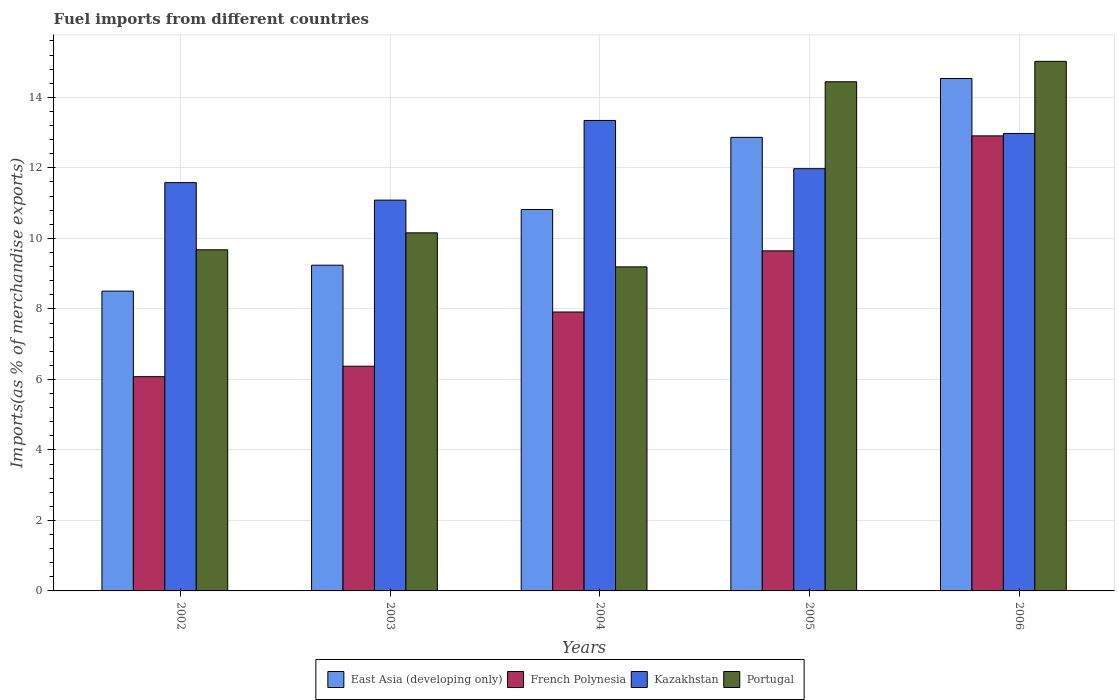How many different coloured bars are there?
Make the answer very short. 4. Are the number of bars on each tick of the X-axis equal?
Your answer should be very brief. Yes. How many bars are there on the 4th tick from the right?
Your answer should be compact. 4. What is the label of the 1st group of bars from the left?
Your answer should be very brief. 2002. In how many cases, is the number of bars for a given year not equal to the number of legend labels?
Give a very brief answer. 0. What is the percentage of imports to different countries in East Asia (developing only) in 2006?
Keep it short and to the point. 14.54. Across all years, what is the maximum percentage of imports to different countries in Kazakhstan?
Offer a terse response. 13.35. Across all years, what is the minimum percentage of imports to different countries in French Polynesia?
Your response must be concise. 6.08. In which year was the percentage of imports to different countries in Portugal minimum?
Make the answer very short. 2004. What is the total percentage of imports to different countries in Kazakhstan in the graph?
Offer a terse response. 60.97. What is the difference between the percentage of imports to different countries in Kazakhstan in 2002 and that in 2003?
Provide a succinct answer. 0.5. What is the difference between the percentage of imports to different countries in East Asia (developing only) in 2005 and the percentage of imports to different countries in Portugal in 2006?
Ensure brevity in your answer.  -2.16. What is the average percentage of imports to different countries in French Polynesia per year?
Offer a terse response. 8.58. In the year 2006, what is the difference between the percentage of imports to different countries in Kazakhstan and percentage of imports to different countries in Portugal?
Ensure brevity in your answer.  -2.05. What is the ratio of the percentage of imports to different countries in French Polynesia in 2003 to that in 2005?
Your answer should be compact. 0.66. Is the percentage of imports to different countries in Kazakhstan in 2002 less than that in 2003?
Your answer should be compact. No. Is the difference between the percentage of imports to different countries in Kazakhstan in 2004 and 2005 greater than the difference between the percentage of imports to different countries in Portugal in 2004 and 2005?
Your answer should be very brief. Yes. What is the difference between the highest and the second highest percentage of imports to different countries in Kazakhstan?
Ensure brevity in your answer.  0.37. What is the difference between the highest and the lowest percentage of imports to different countries in Portugal?
Your answer should be compact. 5.83. In how many years, is the percentage of imports to different countries in East Asia (developing only) greater than the average percentage of imports to different countries in East Asia (developing only) taken over all years?
Provide a succinct answer. 2. What does the 1st bar from the left in 2003 represents?
Provide a succinct answer. East Asia (developing only). What does the 3rd bar from the right in 2003 represents?
Give a very brief answer. French Polynesia. Is it the case that in every year, the sum of the percentage of imports to different countries in East Asia (developing only) and percentage of imports to different countries in French Polynesia is greater than the percentage of imports to different countries in Kazakhstan?
Your response must be concise. Yes. How many bars are there?
Provide a succinct answer. 20. Are all the bars in the graph horizontal?
Your answer should be very brief. No. How many years are there in the graph?
Offer a very short reply. 5. Are the values on the major ticks of Y-axis written in scientific E-notation?
Offer a very short reply. No. Does the graph contain any zero values?
Your answer should be very brief. No. What is the title of the graph?
Offer a very short reply. Fuel imports from different countries. Does "French Polynesia" appear as one of the legend labels in the graph?
Provide a succinct answer. Yes. What is the label or title of the Y-axis?
Keep it short and to the point. Imports(as % of merchandise exports). What is the Imports(as % of merchandise exports) of East Asia (developing only) in 2002?
Your answer should be compact. 8.5. What is the Imports(as % of merchandise exports) in French Polynesia in 2002?
Your answer should be very brief. 6.08. What is the Imports(as % of merchandise exports) in Kazakhstan in 2002?
Ensure brevity in your answer.  11.58. What is the Imports(as % of merchandise exports) in Portugal in 2002?
Keep it short and to the point. 9.68. What is the Imports(as % of merchandise exports) in East Asia (developing only) in 2003?
Ensure brevity in your answer.  9.24. What is the Imports(as % of merchandise exports) in French Polynesia in 2003?
Your answer should be compact. 6.37. What is the Imports(as % of merchandise exports) of Kazakhstan in 2003?
Ensure brevity in your answer.  11.09. What is the Imports(as % of merchandise exports) in Portugal in 2003?
Provide a short and direct response. 10.16. What is the Imports(as % of merchandise exports) of East Asia (developing only) in 2004?
Your answer should be compact. 10.82. What is the Imports(as % of merchandise exports) in French Polynesia in 2004?
Your answer should be very brief. 7.91. What is the Imports(as % of merchandise exports) in Kazakhstan in 2004?
Offer a very short reply. 13.35. What is the Imports(as % of merchandise exports) in Portugal in 2004?
Offer a very short reply. 9.19. What is the Imports(as % of merchandise exports) in East Asia (developing only) in 2005?
Make the answer very short. 12.87. What is the Imports(as % of merchandise exports) of French Polynesia in 2005?
Your answer should be very brief. 9.65. What is the Imports(as % of merchandise exports) of Kazakhstan in 2005?
Give a very brief answer. 11.98. What is the Imports(as % of merchandise exports) of Portugal in 2005?
Ensure brevity in your answer.  14.44. What is the Imports(as % of merchandise exports) of East Asia (developing only) in 2006?
Your answer should be very brief. 14.54. What is the Imports(as % of merchandise exports) in French Polynesia in 2006?
Give a very brief answer. 12.91. What is the Imports(as % of merchandise exports) of Kazakhstan in 2006?
Offer a terse response. 12.98. What is the Imports(as % of merchandise exports) of Portugal in 2006?
Make the answer very short. 15.02. Across all years, what is the maximum Imports(as % of merchandise exports) of East Asia (developing only)?
Provide a short and direct response. 14.54. Across all years, what is the maximum Imports(as % of merchandise exports) in French Polynesia?
Provide a short and direct response. 12.91. Across all years, what is the maximum Imports(as % of merchandise exports) in Kazakhstan?
Make the answer very short. 13.35. Across all years, what is the maximum Imports(as % of merchandise exports) of Portugal?
Your response must be concise. 15.02. Across all years, what is the minimum Imports(as % of merchandise exports) of East Asia (developing only)?
Ensure brevity in your answer.  8.5. Across all years, what is the minimum Imports(as % of merchandise exports) in French Polynesia?
Ensure brevity in your answer.  6.08. Across all years, what is the minimum Imports(as % of merchandise exports) of Kazakhstan?
Ensure brevity in your answer.  11.09. Across all years, what is the minimum Imports(as % of merchandise exports) in Portugal?
Provide a succinct answer. 9.19. What is the total Imports(as % of merchandise exports) in East Asia (developing only) in the graph?
Keep it short and to the point. 55.97. What is the total Imports(as % of merchandise exports) in French Polynesia in the graph?
Make the answer very short. 42.92. What is the total Imports(as % of merchandise exports) in Kazakhstan in the graph?
Keep it short and to the point. 60.97. What is the total Imports(as % of merchandise exports) in Portugal in the graph?
Provide a short and direct response. 58.49. What is the difference between the Imports(as % of merchandise exports) of East Asia (developing only) in 2002 and that in 2003?
Offer a very short reply. -0.74. What is the difference between the Imports(as % of merchandise exports) in French Polynesia in 2002 and that in 2003?
Make the answer very short. -0.3. What is the difference between the Imports(as % of merchandise exports) of Kazakhstan in 2002 and that in 2003?
Your answer should be very brief. 0.5. What is the difference between the Imports(as % of merchandise exports) in Portugal in 2002 and that in 2003?
Offer a terse response. -0.48. What is the difference between the Imports(as % of merchandise exports) in East Asia (developing only) in 2002 and that in 2004?
Provide a short and direct response. -2.32. What is the difference between the Imports(as % of merchandise exports) of French Polynesia in 2002 and that in 2004?
Offer a very short reply. -1.83. What is the difference between the Imports(as % of merchandise exports) of Kazakhstan in 2002 and that in 2004?
Your response must be concise. -1.76. What is the difference between the Imports(as % of merchandise exports) in Portugal in 2002 and that in 2004?
Your answer should be compact. 0.48. What is the difference between the Imports(as % of merchandise exports) in East Asia (developing only) in 2002 and that in 2005?
Your answer should be compact. -4.36. What is the difference between the Imports(as % of merchandise exports) in French Polynesia in 2002 and that in 2005?
Ensure brevity in your answer.  -3.57. What is the difference between the Imports(as % of merchandise exports) of Kazakhstan in 2002 and that in 2005?
Offer a terse response. -0.4. What is the difference between the Imports(as % of merchandise exports) in Portugal in 2002 and that in 2005?
Offer a terse response. -4.77. What is the difference between the Imports(as % of merchandise exports) in East Asia (developing only) in 2002 and that in 2006?
Your answer should be compact. -6.03. What is the difference between the Imports(as % of merchandise exports) of French Polynesia in 2002 and that in 2006?
Your response must be concise. -6.83. What is the difference between the Imports(as % of merchandise exports) in Kazakhstan in 2002 and that in 2006?
Offer a very short reply. -1.39. What is the difference between the Imports(as % of merchandise exports) in Portugal in 2002 and that in 2006?
Your response must be concise. -5.35. What is the difference between the Imports(as % of merchandise exports) of East Asia (developing only) in 2003 and that in 2004?
Your answer should be compact. -1.58. What is the difference between the Imports(as % of merchandise exports) in French Polynesia in 2003 and that in 2004?
Your answer should be very brief. -1.54. What is the difference between the Imports(as % of merchandise exports) in Kazakhstan in 2003 and that in 2004?
Offer a terse response. -2.26. What is the difference between the Imports(as % of merchandise exports) in Portugal in 2003 and that in 2004?
Keep it short and to the point. 0.97. What is the difference between the Imports(as % of merchandise exports) of East Asia (developing only) in 2003 and that in 2005?
Provide a short and direct response. -3.63. What is the difference between the Imports(as % of merchandise exports) of French Polynesia in 2003 and that in 2005?
Offer a very short reply. -3.27. What is the difference between the Imports(as % of merchandise exports) of Kazakhstan in 2003 and that in 2005?
Ensure brevity in your answer.  -0.89. What is the difference between the Imports(as % of merchandise exports) in Portugal in 2003 and that in 2005?
Offer a very short reply. -4.29. What is the difference between the Imports(as % of merchandise exports) of East Asia (developing only) in 2003 and that in 2006?
Provide a succinct answer. -5.3. What is the difference between the Imports(as % of merchandise exports) of French Polynesia in 2003 and that in 2006?
Offer a terse response. -6.53. What is the difference between the Imports(as % of merchandise exports) in Kazakhstan in 2003 and that in 2006?
Give a very brief answer. -1.89. What is the difference between the Imports(as % of merchandise exports) of Portugal in 2003 and that in 2006?
Keep it short and to the point. -4.86. What is the difference between the Imports(as % of merchandise exports) in East Asia (developing only) in 2004 and that in 2005?
Provide a succinct answer. -2.05. What is the difference between the Imports(as % of merchandise exports) of French Polynesia in 2004 and that in 2005?
Make the answer very short. -1.73. What is the difference between the Imports(as % of merchandise exports) of Kazakhstan in 2004 and that in 2005?
Your response must be concise. 1.37. What is the difference between the Imports(as % of merchandise exports) in Portugal in 2004 and that in 2005?
Your answer should be compact. -5.25. What is the difference between the Imports(as % of merchandise exports) of East Asia (developing only) in 2004 and that in 2006?
Offer a very short reply. -3.72. What is the difference between the Imports(as % of merchandise exports) in French Polynesia in 2004 and that in 2006?
Offer a terse response. -5. What is the difference between the Imports(as % of merchandise exports) in Kazakhstan in 2004 and that in 2006?
Ensure brevity in your answer.  0.37. What is the difference between the Imports(as % of merchandise exports) in Portugal in 2004 and that in 2006?
Provide a succinct answer. -5.83. What is the difference between the Imports(as % of merchandise exports) of East Asia (developing only) in 2005 and that in 2006?
Provide a succinct answer. -1.67. What is the difference between the Imports(as % of merchandise exports) of French Polynesia in 2005 and that in 2006?
Keep it short and to the point. -3.26. What is the difference between the Imports(as % of merchandise exports) of Kazakhstan in 2005 and that in 2006?
Ensure brevity in your answer.  -1. What is the difference between the Imports(as % of merchandise exports) in Portugal in 2005 and that in 2006?
Provide a short and direct response. -0.58. What is the difference between the Imports(as % of merchandise exports) in East Asia (developing only) in 2002 and the Imports(as % of merchandise exports) in French Polynesia in 2003?
Your response must be concise. 2.13. What is the difference between the Imports(as % of merchandise exports) of East Asia (developing only) in 2002 and the Imports(as % of merchandise exports) of Kazakhstan in 2003?
Your answer should be very brief. -2.58. What is the difference between the Imports(as % of merchandise exports) of East Asia (developing only) in 2002 and the Imports(as % of merchandise exports) of Portugal in 2003?
Your response must be concise. -1.65. What is the difference between the Imports(as % of merchandise exports) in French Polynesia in 2002 and the Imports(as % of merchandise exports) in Kazakhstan in 2003?
Offer a terse response. -5.01. What is the difference between the Imports(as % of merchandise exports) in French Polynesia in 2002 and the Imports(as % of merchandise exports) in Portugal in 2003?
Keep it short and to the point. -4.08. What is the difference between the Imports(as % of merchandise exports) of Kazakhstan in 2002 and the Imports(as % of merchandise exports) of Portugal in 2003?
Your answer should be compact. 1.42. What is the difference between the Imports(as % of merchandise exports) of East Asia (developing only) in 2002 and the Imports(as % of merchandise exports) of French Polynesia in 2004?
Offer a very short reply. 0.59. What is the difference between the Imports(as % of merchandise exports) in East Asia (developing only) in 2002 and the Imports(as % of merchandise exports) in Kazakhstan in 2004?
Provide a succinct answer. -4.84. What is the difference between the Imports(as % of merchandise exports) in East Asia (developing only) in 2002 and the Imports(as % of merchandise exports) in Portugal in 2004?
Keep it short and to the point. -0.69. What is the difference between the Imports(as % of merchandise exports) of French Polynesia in 2002 and the Imports(as % of merchandise exports) of Kazakhstan in 2004?
Your response must be concise. -7.27. What is the difference between the Imports(as % of merchandise exports) in French Polynesia in 2002 and the Imports(as % of merchandise exports) in Portugal in 2004?
Offer a very short reply. -3.11. What is the difference between the Imports(as % of merchandise exports) of Kazakhstan in 2002 and the Imports(as % of merchandise exports) of Portugal in 2004?
Ensure brevity in your answer.  2.39. What is the difference between the Imports(as % of merchandise exports) of East Asia (developing only) in 2002 and the Imports(as % of merchandise exports) of French Polynesia in 2005?
Your answer should be very brief. -1.14. What is the difference between the Imports(as % of merchandise exports) in East Asia (developing only) in 2002 and the Imports(as % of merchandise exports) in Kazakhstan in 2005?
Give a very brief answer. -3.47. What is the difference between the Imports(as % of merchandise exports) in East Asia (developing only) in 2002 and the Imports(as % of merchandise exports) in Portugal in 2005?
Your response must be concise. -5.94. What is the difference between the Imports(as % of merchandise exports) of French Polynesia in 2002 and the Imports(as % of merchandise exports) of Kazakhstan in 2005?
Provide a succinct answer. -5.9. What is the difference between the Imports(as % of merchandise exports) of French Polynesia in 2002 and the Imports(as % of merchandise exports) of Portugal in 2005?
Make the answer very short. -8.37. What is the difference between the Imports(as % of merchandise exports) in Kazakhstan in 2002 and the Imports(as % of merchandise exports) in Portugal in 2005?
Provide a succinct answer. -2.86. What is the difference between the Imports(as % of merchandise exports) in East Asia (developing only) in 2002 and the Imports(as % of merchandise exports) in French Polynesia in 2006?
Offer a terse response. -4.4. What is the difference between the Imports(as % of merchandise exports) of East Asia (developing only) in 2002 and the Imports(as % of merchandise exports) of Kazakhstan in 2006?
Provide a succinct answer. -4.47. What is the difference between the Imports(as % of merchandise exports) of East Asia (developing only) in 2002 and the Imports(as % of merchandise exports) of Portugal in 2006?
Provide a succinct answer. -6.52. What is the difference between the Imports(as % of merchandise exports) in French Polynesia in 2002 and the Imports(as % of merchandise exports) in Kazakhstan in 2006?
Ensure brevity in your answer.  -6.9. What is the difference between the Imports(as % of merchandise exports) in French Polynesia in 2002 and the Imports(as % of merchandise exports) in Portugal in 2006?
Keep it short and to the point. -8.94. What is the difference between the Imports(as % of merchandise exports) of Kazakhstan in 2002 and the Imports(as % of merchandise exports) of Portugal in 2006?
Your answer should be compact. -3.44. What is the difference between the Imports(as % of merchandise exports) in East Asia (developing only) in 2003 and the Imports(as % of merchandise exports) in French Polynesia in 2004?
Make the answer very short. 1.33. What is the difference between the Imports(as % of merchandise exports) of East Asia (developing only) in 2003 and the Imports(as % of merchandise exports) of Kazakhstan in 2004?
Offer a terse response. -4.11. What is the difference between the Imports(as % of merchandise exports) in East Asia (developing only) in 2003 and the Imports(as % of merchandise exports) in Portugal in 2004?
Offer a very short reply. 0.05. What is the difference between the Imports(as % of merchandise exports) of French Polynesia in 2003 and the Imports(as % of merchandise exports) of Kazakhstan in 2004?
Your answer should be compact. -6.97. What is the difference between the Imports(as % of merchandise exports) in French Polynesia in 2003 and the Imports(as % of merchandise exports) in Portugal in 2004?
Your response must be concise. -2.82. What is the difference between the Imports(as % of merchandise exports) of Kazakhstan in 2003 and the Imports(as % of merchandise exports) of Portugal in 2004?
Your response must be concise. 1.89. What is the difference between the Imports(as % of merchandise exports) in East Asia (developing only) in 2003 and the Imports(as % of merchandise exports) in French Polynesia in 2005?
Make the answer very short. -0.41. What is the difference between the Imports(as % of merchandise exports) of East Asia (developing only) in 2003 and the Imports(as % of merchandise exports) of Kazakhstan in 2005?
Provide a short and direct response. -2.74. What is the difference between the Imports(as % of merchandise exports) in East Asia (developing only) in 2003 and the Imports(as % of merchandise exports) in Portugal in 2005?
Give a very brief answer. -5.2. What is the difference between the Imports(as % of merchandise exports) of French Polynesia in 2003 and the Imports(as % of merchandise exports) of Kazakhstan in 2005?
Provide a short and direct response. -5.6. What is the difference between the Imports(as % of merchandise exports) in French Polynesia in 2003 and the Imports(as % of merchandise exports) in Portugal in 2005?
Make the answer very short. -8.07. What is the difference between the Imports(as % of merchandise exports) of Kazakhstan in 2003 and the Imports(as % of merchandise exports) of Portugal in 2005?
Offer a terse response. -3.36. What is the difference between the Imports(as % of merchandise exports) of East Asia (developing only) in 2003 and the Imports(as % of merchandise exports) of French Polynesia in 2006?
Your answer should be very brief. -3.67. What is the difference between the Imports(as % of merchandise exports) of East Asia (developing only) in 2003 and the Imports(as % of merchandise exports) of Kazakhstan in 2006?
Provide a short and direct response. -3.74. What is the difference between the Imports(as % of merchandise exports) of East Asia (developing only) in 2003 and the Imports(as % of merchandise exports) of Portugal in 2006?
Make the answer very short. -5.78. What is the difference between the Imports(as % of merchandise exports) of French Polynesia in 2003 and the Imports(as % of merchandise exports) of Kazakhstan in 2006?
Make the answer very short. -6.6. What is the difference between the Imports(as % of merchandise exports) of French Polynesia in 2003 and the Imports(as % of merchandise exports) of Portugal in 2006?
Offer a very short reply. -8.65. What is the difference between the Imports(as % of merchandise exports) of Kazakhstan in 2003 and the Imports(as % of merchandise exports) of Portugal in 2006?
Your answer should be very brief. -3.94. What is the difference between the Imports(as % of merchandise exports) in East Asia (developing only) in 2004 and the Imports(as % of merchandise exports) in French Polynesia in 2005?
Your answer should be very brief. 1.17. What is the difference between the Imports(as % of merchandise exports) in East Asia (developing only) in 2004 and the Imports(as % of merchandise exports) in Kazakhstan in 2005?
Keep it short and to the point. -1.16. What is the difference between the Imports(as % of merchandise exports) of East Asia (developing only) in 2004 and the Imports(as % of merchandise exports) of Portugal in 2005?
Your answer should be very brief. -3.62. What is the difference between the Imports(as % of merchandise exports) in French Polynesia in 2004 and the Imports(as % of merchandise exports) in Kazakhstan in 2005?
Keep it short and to the point. -4.07. What is the difference between the Imports(as % of merchandise exports) in French Polynesia in 2004 and the Imports(as % of merchandise exports) in Portugal in 2005?
Give a very brief answer. -6.53. What is the difference between the Imports(as % of merchandise exports) of Kazakhstan in 2004 and the Imports(as % of merchandise exports) of Portugal in 2005?
Offer a very short reply. -1.1. What is the difference between the Imports(as % of merchandise exports) in East Asia (developing only) in 2004 and the Imports(as % of merchandise exports) in French Polynesia in 2006?
Give a very brief answer. -2.09. What is the difference between the Imports(as % of merchandise exports) in East Asia (developing only) in 2004 and the Imports(as % of merchandise exports) in Kazakhstan in 2006?
Make the answer very short. -2.16. What is the difference between the Imports(as % of merchandise exports) in East Asia (developing only) in 2004 and the Imports(as % of merchandise exports) in Portugal in 2006?
Your answer should be compact. -4.2. What is the difference between the Imports(as % of merchandise exports) in French Polynesia in 2004 and the Imports(as % of merchandise exports) in Kazakhstan in 2006?
Your answer should be very brief. -5.06. What is the difference between the Imports(as % of merchandise exports) of French Polynesia in 2004 and the Imports(as % of merchandise exports) of Portugal in 2006?
Your response must be concise. -7.11. What is the difference between the Imports(as % of merchandise exports) of Kazakhstan in 2004 and the Imports(as % of merchandise exports) of Portugal in 2006?
Offer a very short reply. -1.68. What is the difference between the Imports(as % of merchandise exports) in East Asia (developing only) in 2005 and the Imports(as % of merchandise exports) in French Polynesia in 2006?
Your response must be concise. -0.04. What is the difference between the Imports(as % of merchandise exports) of East Asia (developing only) in 2005 and the Imports(as % of merchandise exports) of Kazakhstan in 2006?
Keep it short and to the point. -0.11. What is the difference between the Imports(as % of merchandise exports) of East Asia (developing only) in 2005 and the Imports(as % of merchandise exports) of Portugal in 2006?
Your answer should be very brief. -2.16. What is the difference between the Imports(as % of merchandise exports) in French Polynesia in 2005 and the Imports(as % of merchandise exports) in Kazakhstan in 2006?
Make the answer very short. -3.33. What is the difference between the Imports(as % of merchandise exports) of French Polynesia in 2005 and the Imports(as % of merchandise exports) of Portugal in 2006?
Ensure brevity in your answer.  -5.38. What is the difference between the Imports(as % of merchandise exports) of Kazakhstan in 2005 and the Imports(as % of merchandise exports) of Portugal in 2006?
Your answer should be very brief. -3.04. What is the average Imports(as % of merchandise exports) of East Asia (developing only) per year?
Ensure brevity in your answer.  11.19. What is the average Imports(as % of merchandise exports) in French Polynesia per year?
Give a very brief answer. 8.58. What is the average Imports(as % of merchandise exports) of Kazakhstan per year?
Offer a terse response. 12.19. What is the average Imports(as % of merchandise exports) in Portugal per year?
Keep it short and to the point. 11.7. In the year 2002, what is the difference between the Imports(as % of merchandise exports) in East Asia (developing only) and Imports(as % of merchandise exports) in French Polynesia?
Keep it short and to the point. 2.43. In the year 2002, what is the difference between the Imports(as % of merchandise exports) of East Asia (developing only) and Imports(as % of merchandise exports) of Kazakhstan?
Make the answer very short. -3.08. In the year 2002, what is the difference between the Imports(as % of merchandise exports) of East Asia (developing only) and Imports(as % of merchandise exports) of Portugal?
Provide a short and direct response. -1.17. In the year 2002, what is the difference between the Imports(as % of merchandise exports) in French Polynesia and Imports(as % of merchandise exports) in Kazakhstan?
Your answer should be very brief. -5.5. In the year 2002, what is the difference between the Imports(as % of merchandise exports) in French Polynesia and Imports(as % of merchandise exports) in Portugal?
Ensure brevity in your answer.  -3.6. In the year 2002, what is the difference between the Imports(as % of merchandise exports) of Kazakhstan and Imports(as % of merchandise exports) of Portugal?
Your answer should be compact. 1.91. In the year 2003, what is the difference between the Imports(as % of merchandise exports) of East Asia (developing only) and Imports(as % of merchandise exports) of French Polynesia?
Offer a very short reply. 2.87. In the year 2003, what is the difference between the Imports(as % of merchandise exports) of East Asia (developing only) and Imports(as % of merchandise exports) of Kazakhstan?
Offer a terse response. -1.85. In the year 2003, what is the difference between the Imports(as % of merchandise exports) of East Asia (developing only) and Imports(as % of merchandise exports) of Portugal?
Make the answer very short. -0.92. In the year 2003, what is the difference between the Imports(as % of merchandise exports) in French Polynesia and Imports(as % of merchandise exports) in Kazakhstan?
Give a very brief answer. -4.71. In the year 2003, what is the difference between the Imports(as % of merchandise exports) of French Polynesia and Imports(as % of merchandise exports) of Portugal?
Make the answer very short. -3.78. In the year 2003, what is the difference between the Imports(as % of merchandise exports) of Kazakhstan and Imports(as % of merchandise exports) of Portugal?
Offer a terse response. 0.93. In the year 2004, what is the difference between the Imports(as % of merchandise exports) in East Asia (developing only) and Imports(as % of merchandise exports) in French Polynesia?
Keep it short and to the point. 2.91. In the year 2004, what is the difference between the Imports(as % of merchandise exports) in East Asia (developing only) and Imports(as % of merchandise exports) in Kazakhstan?
Keep it short and to the point. -2.53. In the year 2004, what is the difference between the Imports(as % of merchandise exports) of East Asia (developing only) and Imports(as % of merchandise exports) of Portugal?
Provide a succinct answer. 1.63. In the year 2004, what is the difference between the Imports(as % of merchandise exports) in French Polynesia and Imports(as % of merchandise exports) in Kazakhstan?
Ensure brevity in your answer.  -5.43. In the year 2004, what is the difference between the Imports(as % of merchandise exports) in French Polynesia and Imports(as % of merchandise exports) in Portugal?
Offer a terse response. -1.28. In the year 2004, what is the difference between the Imports(as % of merchandise exports) in Kazakhstan and Imports(as % of merchandise exports) in Portugal?
Your answer should be compact. 4.15. In the year 2005, what is the difference between the Imports(as % of merchandise exports) in East Asia (developing only) and Imports(as % of merchandise exports) in French Polynesia?
Offer a very short reply. 3.22. In the year 2005, what is the difference between the Imports(as % of merchandise exports) in East Asia (developing only) and Imports(as % of merchandise exports) in Kazakhstan?
Provide a succinct answer. 0.89. In the year 2005, what is the difference between the Imports(as % of merchandise exports) of East Asia (developing only) and Imports(as % of merchandise exports) of Portugal?
Provide a succinct answer. -1.58. In the year 2005, what is the difference between the Imports(as % of merchandise exports) in French Polynesia and Imports(as % of merchandise exports) in Kazakhstan?
Provide a short and direct response. -2.33. In the year 2005, what is the difference between the Imports(as % of merchandise exports) of French Polynesia and Imports(as % of merchandise exports) of Portugal?
Your answer should be very brief. -4.8. In the year 2005, what is the difference between the Imports(as % of merchandise exports) in Kazakhstan and Imports(as % of merchandise exports) in Portugal?
Offer a terse response. -2.47. In the year 2006, what is the difference between the Imports(as % of merchandise exports) of East Asia (developing only) and Imports(as % of merchandise exports) of French Polynesia?
Your response must be concise. 1.63. In the year 2006, what is the difference between the Imports(as % of merchandise exports) of East Asia (developing only) and Imports(as % of merchandise exports) of Kazakhstan?
Provide a succinct answer. 1.56. In the year 2006, what is the difference between the Imports(as % of merchandise exports) in East Asia (developing only) and Imports(as % of merchandise exports) in Portugal?
Your answer should be very brief. -0.49. In the year 2006, what is the difference between the Imports(as % of merchandise exports) in French Polynesia and Imports(as % of merchandise exports) in Kazakhstan?
Offer a terse response. -0.07. In the year 2006, what is the difference between the Imports(as % of merchandise exports) in French Polynesia and Imports(as % of merchandise exports) in Portugal?
Make the answer very short. -2.11. In the year 2006, what is the difference between the Imports(as % of merchandise exports) of Kazakhstan and Imports(as % of merchandise exports) of Portugal?
Your response must be concise. -2.05. What is the ratio of the Imports(as % of merchandise exports) in East Asia (developing only) in 2002 to that in 2003?
Your answer should be compact. 0.92. What is the ratio of the Imports(as % of merchandise exports) of French Polynesia in 2002 to that in 2003?
Give a very brief answer. 0.95. What is the ratio of the Imports(as % of merchandise exports) in Kazakhstan in 2002 to that in 2003?
Your answer should be compact. 1.04. What is the ratio of the Imports(as % of merchandise exports) in Portugal in 2002 to that in 2003?
Provide a succinct answer. 0.95. What is the ratio of the Imports(as % of merchandise exports) of East Asia (developing only) in 2002 to that in 2004?
Ensure brevity in your answer.  0.79. What is the ratio of the Imports(as % of merchandise exports) in French Polynesia in 2002 to that in 2004?
Your answer should be very brief. 0.77. What is the ratio of the Imports(as % of merchandise exports) in Kazakhstan in 2002 to that in 2004?
Keep it short and to the point. 0.87. What is the ratio of the Imports(as % of merchandise exports) in Portugal in 2002 to that in 2004?
Your response must be concise. 1.05. What is the ratio of the Imports(as % of merchandise exports) of East Asia (developing only) in 2002 to that in 2005?
Make the answer very short. 0.66. What is the ratio of the Imports(as % of merchandise exports) in French Polynesia in 2002 to that in 2005?
Provide a succinct answer. 0.63. What is the ratio of the Imports(as % of merchandise exports) of Kazakhstan in 2002 to that in 2005?
Ensure brevity in your answer.  0.97. What is the ratio of the Imports(as % of merchandise exports) in Portugal in 2002 to that in 2005?
Offer a terse response. 0.67. What is the ratio of the Imports(as % of merchandise exports) in East Asia (developing only) in 2002 to that in 2006?
Your answer should be compact. 0.59. What is the ratio of the Imports(as % of merchandise exports) of French Polynesia in 2002 to that in 2006?
Your response must be concise. 0.47. What is the ratio of the Imports(as % of merchandise exports) of Kazakhstan in 2002 to that in 2006?
Provide a short and direct response. 0.89. What is the ratio of the Imports(as % of merchandise exports) in Portugal in 2002 to that in 2006?
Give a very brief answer. 0.64. What is the ratio of the Imports(as % of merchandise exports) in East Asia (developing only) in 2003 to that in 2004?
Your answer should be compact. 0.85. What is the ratio of the Imports(as % of merchandise exports) in French Polynesia in 2003 to that in 2004?
Your response must be concise. 0.81. What is the ratio of the Imports(as % of merchandise exports) in Kazakhstan in 2003 to that in 2004?
Your answer should be compact. 0.83. What is the ratio of the Imports(as % of merchandise exports) in Portugal in 2003 to that in 2004?
Offer a very short reply. 1.1. What is the ratio of the Imports(as % of merchandise exports) of East Asia (developing only) in 2003 to that in 2005?
Give a very brief answer. 0.72. What is the ratio of the Imports(as % of merchandise exports) in French Polynesia in 2003 to that in 2005?
Provide a succinct answer. 0.66. What is the ratio of the Imports(as % of merchandise exports) in Kazakhstan in 2003 to that in 2005?
Give a very brief answer. 0.93. What is the ratio of the Imports(as % of merchandise exports) of Portugal in 2003 to that in 2005?
Provide a short and direct response. 0.7. What is the ratio of the Imports(as % of merchandise exports) in East Asia (developing only) in 2003 to that in 2006?
Give a very brief answer. 0.64. What is the ratio of the Imports(as % of merchandise exports) of French Polynesia in 2003 to that in 2006?
Your answer should be very brief. 0.49. What is the ratio of the Imports(as % of merchandise exports) in Kazakhstan in 2003 to that in 2006?
Give a very brief answer. 0.85. What is the ratio of the Imports(as % of merchandise exports) of Portugal in 2003 to that in 2006?
Provide a short and direct response. 0.68. What is the ratio of the Imports(as % of merchandise exports) of East Asia (developing only) in 2004 to that in 2005?
Your response must be concise. 0.84. What is the ratio of the Imports(as % of merchandise exports) of French Polynesia in 2004 to that in 2005?
Make the answer very short. 0.82. What is the ratio of the Imports(as % of merchandise exports) of Kazakhstan in 2004 to that in 2005?
Provide a succinct answer. 1.11. What is the ratio of the Imports(as % of merchandise exports) in Portugal in 2004 to that in 2005?
Your answer should be compact. 0.64. What is the ratio of the Imports(as % of merchandise exports) in East Asia (developing only) in 2004 to that in 2006?
Ensure brevity in your answer.  0.74. What is the ratio of the Imports(as % of merchandise exports) in French Polynesia in 2004 to that in 2006?
Your answer should be compact. 0.61. What is the ratio of the Imports(as % of merchandise exports) in Kazakhstan in 2004 to that in 2006?
Give a very brief answer. 1.03. What is the ratio of the Imports(as % of merchandise exports) of Portugal in 2004 to that in 2006?
Your response must be concise. 0.61. What is the ratio of the Imports(as % of merchandise exports) of East Asia (developing only) in 2005 to that in 2006?
Offer a very short reply. 0.89. What is the ratio of the Imports(as % of merchandise exports) of French Polynesia in 2005 to that in 2006?
Provide a succinct answer. 0.75. What is the ratio of the Imports(as % of merchandise exports) in Kazakhstan in 2005 to that in 2006?
Provide a short and direct response. 0.92. What is the ratio of the Imports(as % of merchandise exports) of Portugal in 2005 to that in 2006?
Provide a succinct answer. 0.96. What is the difference between the highest and the second highest Imports(as % of merchandise exports) in East Asia (developing only)?
Offer a very short reply. 1.67. What is the difference between the highest and the second highest Imports(as % of merchandise exports) of French Polynesia?
Offer a very short reply. 3.26. What is the difference between the highest and the second highest Imports(as % of merchandise exports) in Kazakhstan?
Ensure brevity in your answer.  0.37. What is the difference between the highest and the second highest Imports(as % of merchandise exports) of Portugal?
Provide a succinct answer. 0.58. What is the difference between the highest and the lowest Imports(as % of merchandise exports) in East Asia (developing only)?
Provide a short and direct response. 6.03. What is the difference between the highest and the lowest Imports(as % of merchandise exports) in French Polynesia?
Offer a terse response. 6.83. What is the difference between the highest and the lowest Imports(as % of merchandise exports) of Kazakhstan?
Your answer should be very brief. 2.26. What is the difference between the highest and the lowest Imports(as % of merchandise exports) of Portugal?
Make the answer very short. 5.83. 